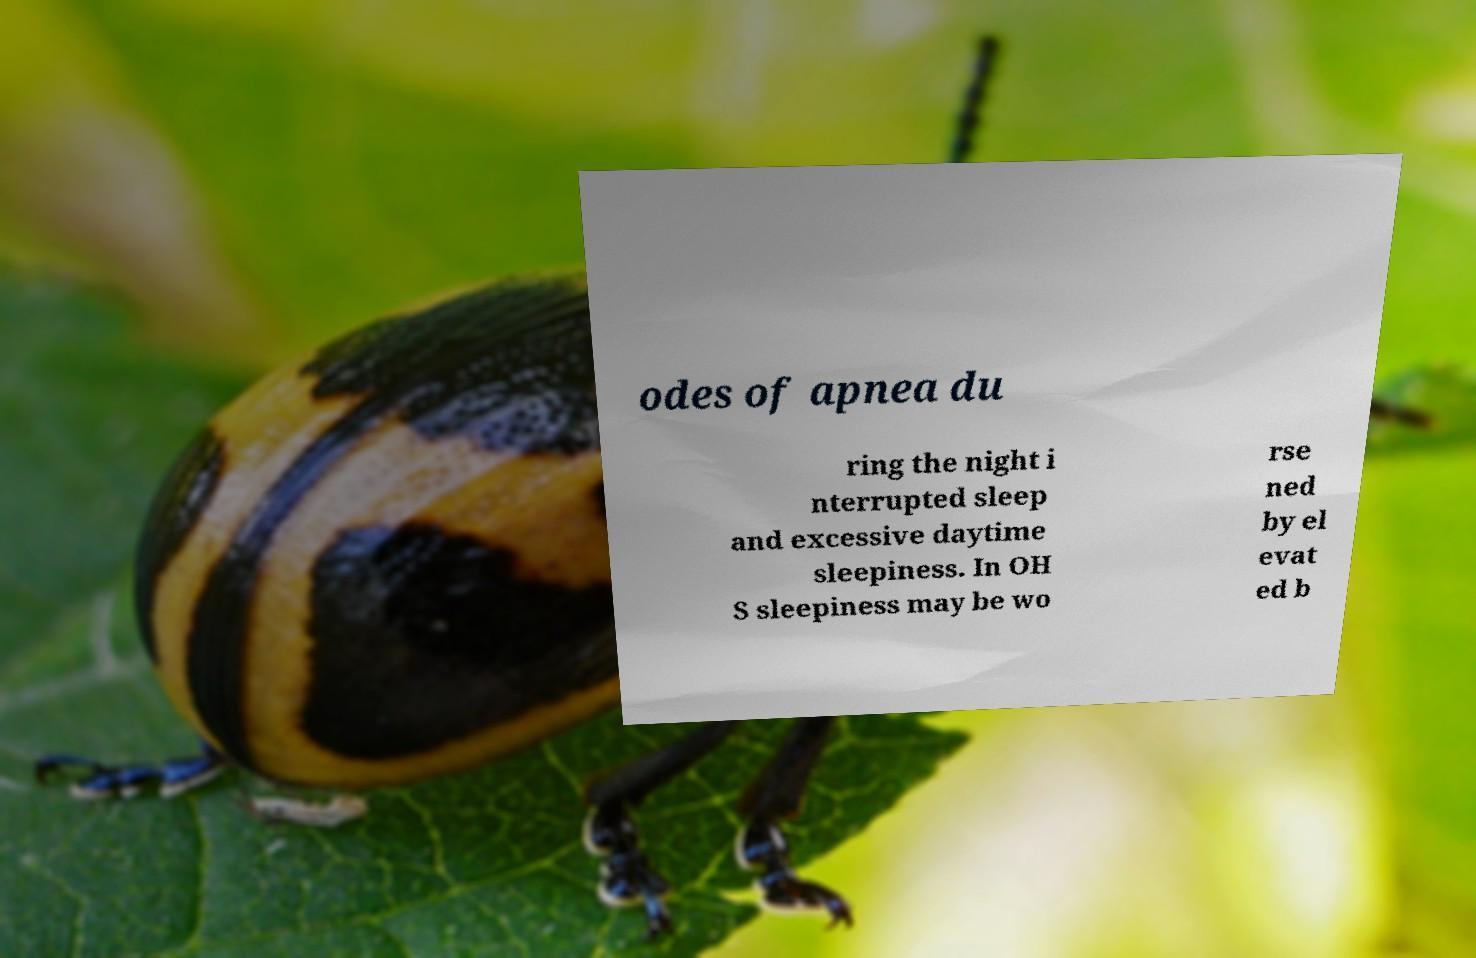Please identify and transcribe the text found in this image. odes of apnea du ring the night i nterrupted sleep and excessive daytime sleepiness. In OH S sleepiness may be wo rse ned by el evat ed b 